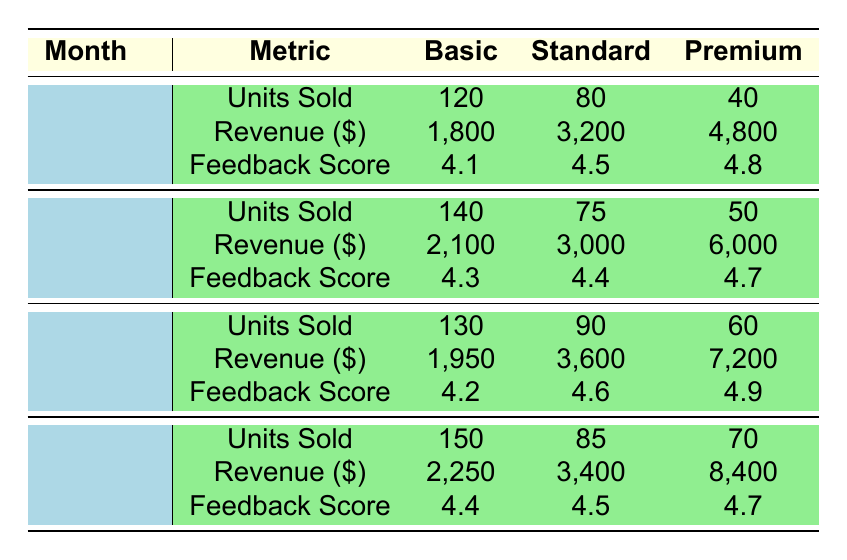What was the total revenue from the Premium pricing tier in January? In January, the revenue from the Premium tier is 4,800. This is a direct retrieval of the revenue listed under January for the Premium pricing tier.
Answer: 4800 How many units were sold in February across all pricing tiers? To find the total units sold in February, we add the units sold for each pricing tier: 140 (Basic) + 75 (Standard) + 50 (Premium) = 265.
Answer: 265 Did the customer feedback score for the Basic tier improve from January to April? The feedback scores for the Basic tier are 4.1 (January) and 4.4 (April). Since 4.4 is greater than 4.1, it indicates an improvement in the score over the period.
Answer: Yes What is the average customer feedback score for the Standard pricing tier over the months? The feedback scores for the Standard tier are 4.5 (January), 4.4 (February), 4.6 (March), and 4.5 (April). We sum these scores: (4.5 + 4.4 + 4.6 + 4.5) = 18. The average is 18/4 = 4.5.
Answer: 4.5 Which month had the highest units sold in the Premium pricing tier? By examining the units sold in the Premium tier across the months: 40 (January), 50 (February), 60 (March), and 70 (April), April has the highest units sold at 70.
Answer: April What was the change in revenue for the Standard pricing tier from March to April? The revenue for the Standard tier in March is 3,600 and in April is 3,400. The change is 3,400 - 3,600 = -200, indicating a decrease of 200.
Answer: -200 Was the customer feedback score for the Basic tier in March higher than the Standard tier in the same month? The customer feedback score for Basic is 4.2 and for Standard is 4.6 in March. Since 4.2 is less than 4.6, the Basic tier does not have a higher score.
Answer: No What is the total revenue generated from all pricing tiers in February? The revenues in February are: 2,100 (Basic) + 3,000 (Standard) + 6,000 (Premium) = 11,100. Therefore, the total revenue for February is 11,100.
Answer: 11100 